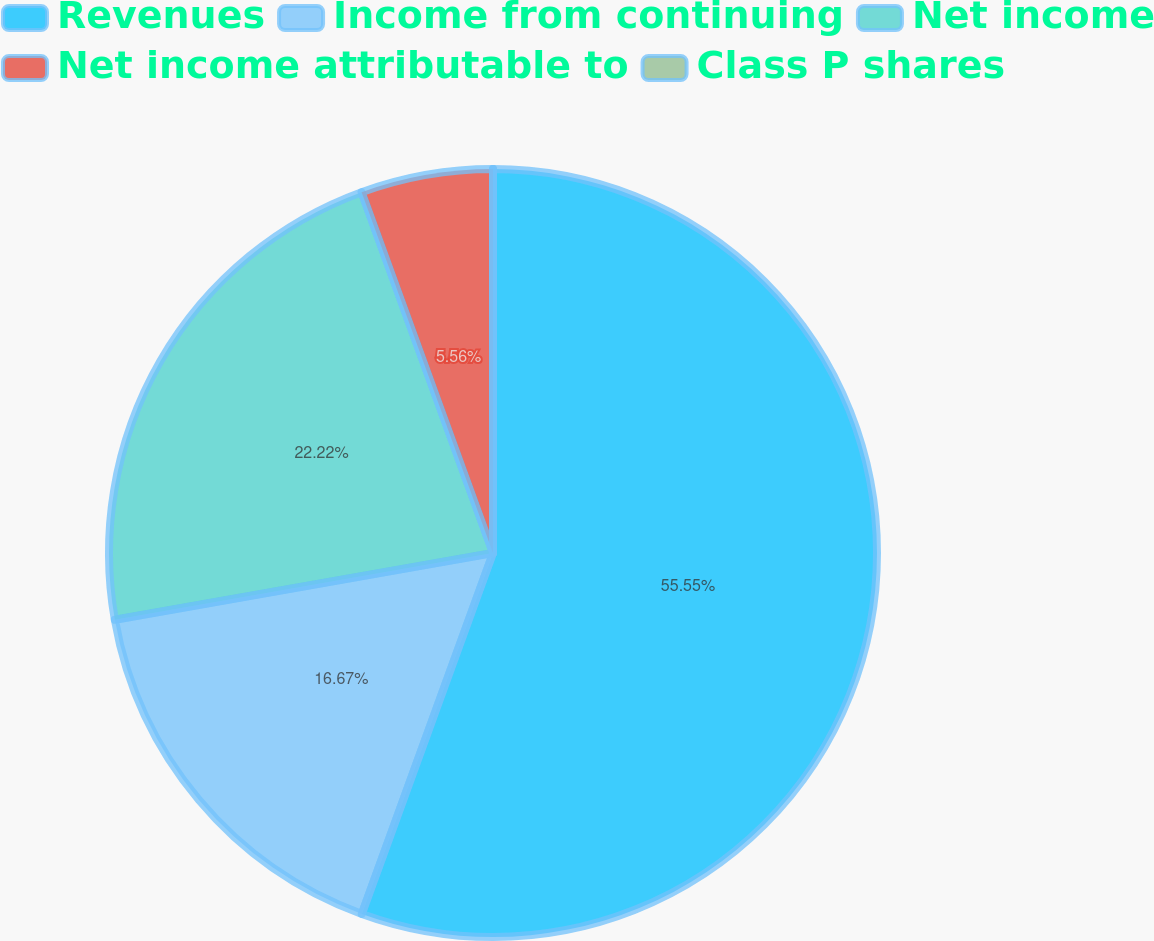Convert chart to OTSL. <chart><loc_0><loc_0><loc_500><loc_500><pie_chart><fcel>Revenues<fcel>Income from continuing<fcel>Net income<fcel>Net income attributable to<fcel>Class P shares<nl><fcel>55.55%<fcel>16.67%<fcel>22.22%<fcel>5.56%<fcel>0.0%<nl></chart> 